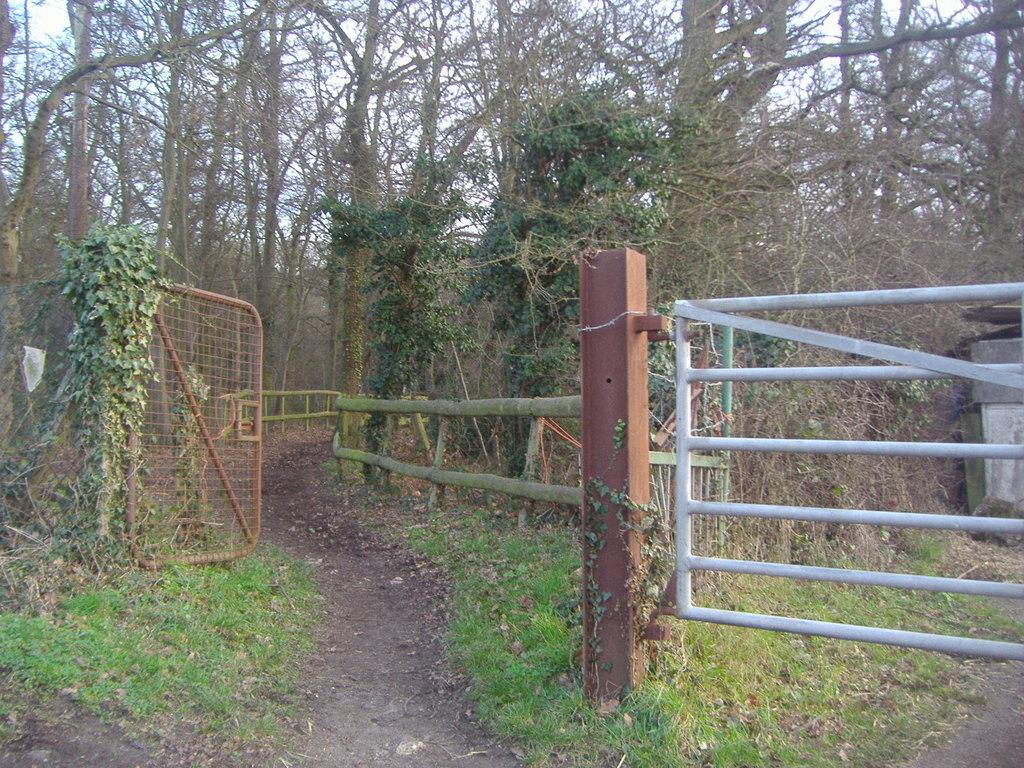What type of structure can be seen in the image? There is a railing and a gate in the image. What color are the trees in the image? The trees in the image are in green color. What is the color of the sky in the image? The sky is in white color in the image. What type of leather is being used to make a list in the image? There is no leather or list present in the image. What type of game is being played in the image? There is no game or play depicted in the image. 